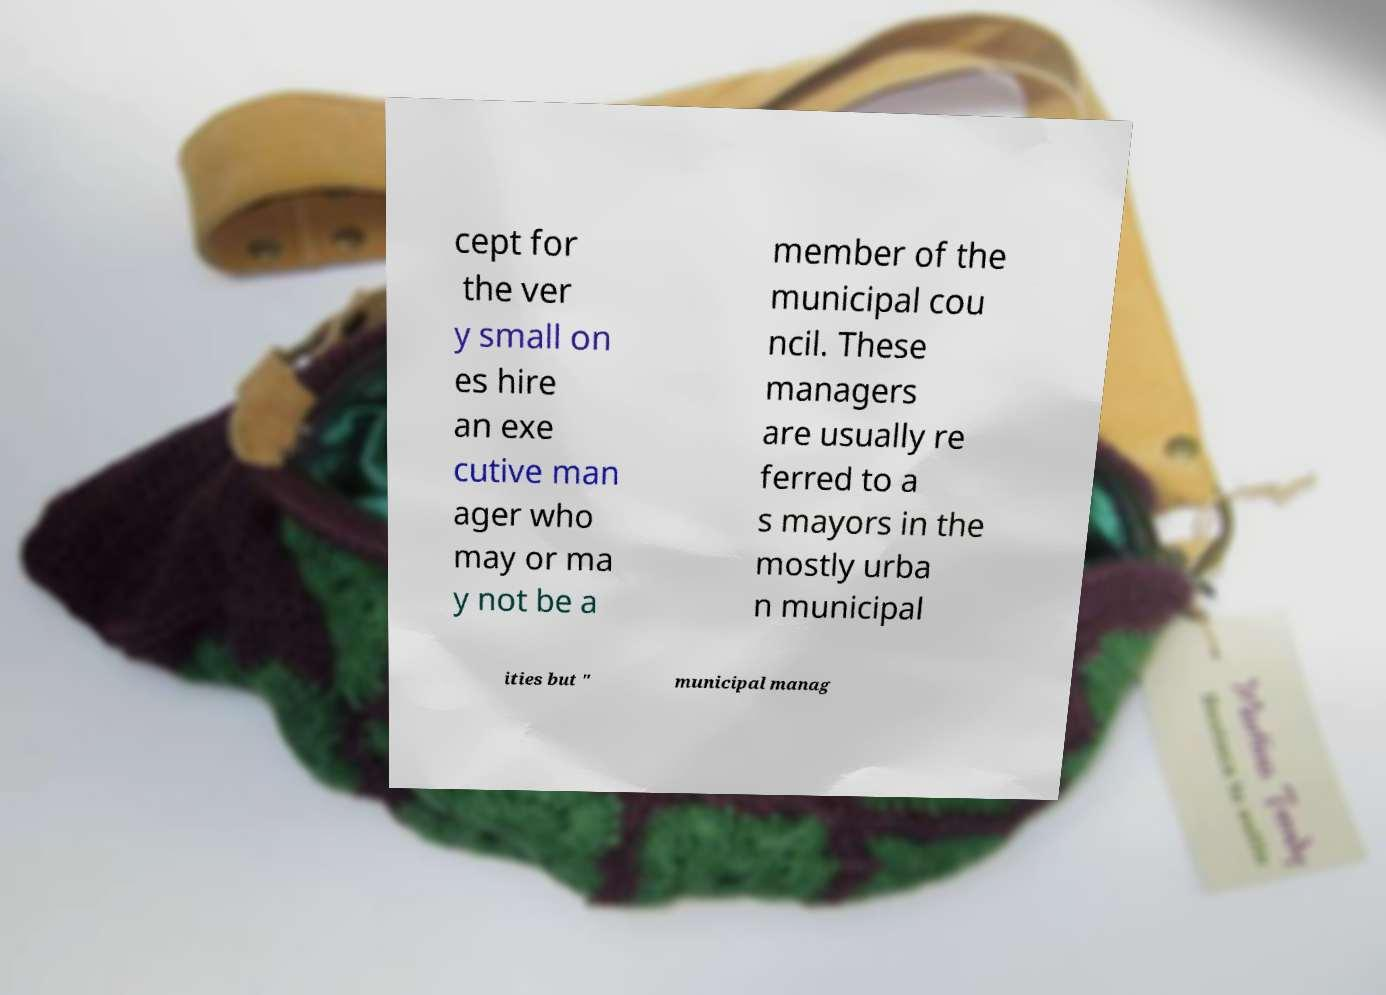There's text embedded in this image that I need extracted. Can you transcribe it verbatim? cept for the ver y small on es hire an exe cutive man ager who may or ma y not be a member of the municipal cou ncil. These managers are usually re ferred to a s mayors in the mostly urba n municipal ities but " municipal manag 